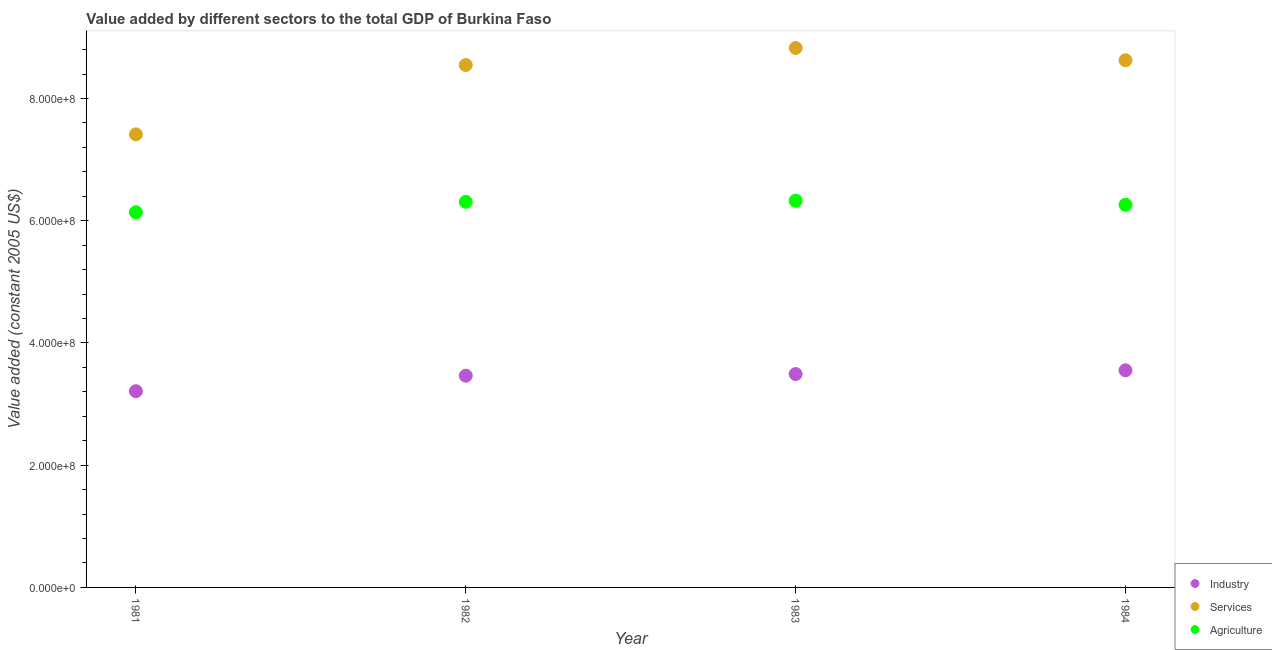What is the value added by services in 1982?
Keep it short and to the point. 8.55e+08. Across all years, what is the maximum value added by agricultural sector?
Provide a succinct answer. 6.33e+08. Across all years, what is the minimum value added by industrial sector?
Your answer should be very brief. 3.21e+08. In which year was the value added by agricultural sector minimum?
Offer a very short reply. 1981. What is the total value added by agricultural sector in the graph?
Offer a terse response. 2.50e+09. What is the difference between the value added by services in 1981 and that in 1984?
Your response must be concise. -1.21e+08. What is the difference between the value added by industrial sector in 1983 and the value added by services in 1984?
Make the answer very short. -5.13e+08. What is the average value added by agricultural sector per year?
Provide a short and direct response. 6.26e+08. In the year 1983, what is the difference between the value added by services and value added by industrial sector?
Your response must be concise. 5.33e+08. What is the ratio of the value added by industrial sector in 1981 to that in 1982?
Offer a terse response. 0.93. Is the value added by agricultural sector in 1983 less than that in 1984?
Offer a very short reply. No. Is the difference between the value added by industrial sector in 1981 and 1983 greater than the difference between the value added by agricultural sector in 1981 and 1983?
Provide a short and direct response. No. What is the difference between the highest and the second highest value added by industrial sector?
Your answer should be very brief. 6.10e+06. What is the difference between the highest and the lowest value added by industrial sector?
Give a very brief answer. 3.42e+07. In how many years, is the value added by agricultural sector greater than the average value added by agricultural sector taken over all years?
Your response must be concise. 3. Is it the case that in every year, the sum of the value added by industrial sector and value added by services is greater than the value added by agricultural sector?
Provide a succinct answer. Yes. Is the value added by industrial sector strictly less than the value added by agricultural sector over the years?
Provide a succinct answer. Yes. How many years are there in the graph?
Give a very brief answer. 4. Where does the legend appear in the graph?
Keep it short and to the point. Bottom right. How are the legend labels stacked?
Provide a succinct answer. Vertical. What is the title of the graph?
Your response must be concise. Value added by different sectors to the total GDP of Burkina Faso. What is the label or title of the X-axis?
Provide a succinct answer. Year. What is the label or title of the Y-axis?
Provide a succinct answer. Value added (constant 2005 US$). What is the Value added (constant 2005 US$) of Industry in 1981?
Your answer should be very brief. 3.21e+08. What is the Value added (constant 2005 US$) in Services in 1981?
Keep it short and to the point. 7.41e+08. What is the Value added (constant 2005 US$) of Agriculture in 1981?
Your answer should be compact. 6.14e+08. What is the Value added (constant 2005 US$) of Industry in 1982?
Give a very brief answer. 3.46e+08. What is the Value added (constant 2005 US$) of Services in 1982?
Keep it short and to the point. 8.55e+08. What is the Value added (constant 2005 US$) of Agriculture in 1982?
Your answer should be very brief. 6.31e+08. What is the Value added (constant 2005 US$) in Industry in 1983?
Provide a short and direct response. 3.49e+08. What is the Value added (constant 2005 US$) in Services in 1983?
Provide a succinct answer. 8.83e+08. What is the Value added (constant 2005 US$) of Agriculture in 1983?
Give a very brief answer. 6.33e+08. What is the Value added (constant 2005 US$) of Industry in 1984?
Your answer should be very brief. 3.55e+08. What is the Value added (constant 2005 US$) in Services in 1984?
Ensure brevity in your answer.  8.62e+08. What is the Value added (constant 2005 US$) of Agriculture in 1984?
Provide a short and direct response. 6.26e+08. Across all years, what is the maximum Value added (constant 2005 US$) in Industry?
Your answer should be very brief. 3.55e+08. Across all years, what is the maximum Value added (constant 2005 US$) of Services?
Offer a very short reply. 8.83e+08. Across all years, what is the maximum Value added (constant 2005 US$) of Agriculture?
Make the answer very short. 6.33e+08. Across all years, what is the minimum Value added (constant 2005 US$) of Industry?
Your response must be concise. 3.21e+08. Across all years, what is the minimum Value added (constant 2005 US$) in Services?
Make the answer very short. 7.41e+08. Across all years, what is the minimum Value added (constant 2005 US$) of Agriculture?
Provide a short and direct response. 6.14e+08. What is the total Value added (constant 2005 US$) in Industry in the graph?
Your response must be concise. 1.37e+09. What is the total Value added (constant 2005 US$) in Services in the graph?
Provide a short and direct response. 3.34e+09. What is the total Value added (constant 2005 US$) in Agriculture in the graph?
Provide a succinct answer. 2.50e+09. What is the difference between the Value added (constant 2005 US$) of Industry in 1981 and that in 1982?
Make the answer very short. -2.54e+07. What is the difference between the Value added (constant 2005 US$) of Services in 1981 and that in 1982?
Offer a terse response. -1.13e+08. What is the difference between the Value added (constant 2005 US$) in Agriculture in 1981 and that in 1982?
Give a very brief answer. -1.71e+07. What is the difference between the Value added (constant 2005 US$) in Industry in 1981 and that in 1983?
Provide a short and direct response. -2.81e+07. What is the difference between the Value added (constant 2005 US$) of Services in 1981 and that in 1983?
Provide a succinct answer. -1.41e+08. What is the difference between the Value added (constant 2005 US$) in Agriculture in 1981 and that in 1983?
Give a very brief answer. -1.89e+07. What is the difference between the Value added (constant 2005 US$) of Industry in 1981 and that in 1984?
Provide a succinct answer. -3.42e+07. What is the difference between the Value added (constant 2005 US$) of Services in 1981 and that in 1984?
Provide a short and direct response. -1.21e+08. What is the difference between the Value added (constant 2005 US$) in Agriculture in 1981 and that in 1984?
Your answer should be very brief. -1.22e+07. What is the difference between the Value added (constant 2005 US$) of Industry in 1982 and that in 1983?
Provide a short and direct response. -2.71e+06. What is the difference between the Value added (constant 2005 US$) of Services in 1982 and that in 1983?
Your response must be concise. -2.79e+07. What is the difference between the Value added (constant 2005 US$) of Agriculture in 1982 and that in 1983?
Ensure brevity in your answer.  -1.83e+06. What is the difference between the Value added (constant 2005 US$) in Industry in 1982 and that in 1984?
Your response must be concise. -8.82e+06. What is the difference between the Value added (constant 2005 US$) in Services in 1982 and that in 1984?
Ensure brevity in your answer.  -7.79e+06. What is the difference between the Value added (constant 2005 US$) in Agriculture in 1982 and that in 1984?
Provide a short and direct response. 4.89e+06. What is the difference between the Value added (constant 2005 US$) of Industry in 1983 and that in 1984?
Provide a short and direct response. -6.10e+06. What is the difference between the Value added (constant 2005 US$) of Services in 1983 and that in 1984?
Your response must be concise. 2.01e+07. What is the difference between the Value added (constant 2005 US$) of Agriculture in 1983 and that in 1984?
Your response must be concise. 6.72e+06. What is the difference between the Value added (constant 2005 US$) of Industry in 1981 and the Value added (constant 2005 US$) of Services in 1982?
Give a very brief answer. -5.34e+08. What is the difference between the Value added (constant 2005 US$) of Industry in 1981 and the Value added (constant 2005 US$) of Agriculture in 1982?
Provide a succinct answer. -3.10e+08. What is the difference between the Value added (constant 2005 US$) in Services in 1981 and the Value added (constant 2005 US$) in Agriculture in 1982?
Make the answer very short. 1.10e+08. What is the difference between the Value added (constant 2005 US$) of Industry in 1981 and the Value added (constant 2005 US$) of Services in 1983?
Offer a very short reply. -5.62e+08. What is the difference between the Value added (constant 2005 US$) of Industry in 1981 and the Value added (constant 2005 US$) of Agriculture in 1983?
Keep it short and to the point. -3.12e+08. What is the difference between the Value added (constant 2005 US$) of Services in 1981 and the Value added (constant 2005 US$) of Agriculture in 1983?
Offer a terse response. 1.08e+08. What is the difference between the Value added (constant 2005 US$) in Industry in 1981 and the Value added (constant 2005 US$) in Services in 1984?
Your answer should be compact. -5.41e+08. What is the difference between the Value added (constant 2005 US$) of Industry in 1981 and the Value added (constant 2005 US$) of Agriculture in 1984?
Keep it short and to the point. -3.05e+08. What is the difference between the Value added (constant 2005 US$) of Services in 1981 and the Value added (constant 2005 US$) of Agriculture in 1984?
Ensure brevity in your answer.  1.15e+08. What is the difference between the Value added (constant 2005 US$) in Industry in 1982 and the Value added (constant 2005 US$) in Services in 1983?
Your response must be concise. -5.36e+08. What is the difference between the Value added (constant 2005 US$) in Industry in 1982 and the Value added (constant 2005 US$) in Agriculture in 1983?
Offer a very short reply. -2.86e+08. What is the difference between the Value added (constant 2005 US$) of Services in 1982 and the Value added (constant 2005 US$) of Agriculture in 1983?
Ensure brevity in your answer.  2.22e+08. What is the difference between the Value added (constant 2005 US$) of Industry in 1982 and the Value added (constant 2005 US$) of Services in 1984?
Offer a very short reply. -5.16e+08. What is the difference between the Value added (constant 2005 US$) in Industry in 1982 and the Value added (constant 2005 US$) in Agriculture in 1984?
Provide a succinct answer. -2.80e+08. What is the difference between the Value added (constant 2005 US$) in Services in 1982 and the Value added (constant 2005 US$) in Agriculture in 1984?
Offer a terse response. 2.29e+08. What is the difference between the Value added (constant 2005 US$) of Industry in 1983 and the Value added (constant 2005 US$) of Services in 1984?
Your answer should be very brief. -5.13e+08. What is the difference between the Value added (constant 2005 US$) in Industry in 1983 and the Value added (constant 2005 US$) in Agriculture in 1984?
Your answer should be compact. -2.77e+08. What is the difference between the Value added (constant 2005 US$) in Services in 1983 and the Value added (constant 2005 US$) in Agriculture in 1984?
Offer a terse response. 2.57e+08. What is the average Value added (constant 2005 US$) of Industry per year?
Your response must be concise. 3.43e+08. What is the average Value added (constant 2005 US$) of Services per year?
Offer a very short reply. 8.35e+08. What is the average Value added (constant 2005 US$) of Agriculture per year?
Give a very brief answer. 6.26e+08. In the year 1981, what is the difference between the Value added (constant 2005 US$) of Industry and Value added (constant 2005 US$) of Services?
Your response must be concise. -4.20e+08. In the year 1981, what is the difference between the Value added (constant 2005 US$) in Industry and Value added (constant 2005 US$) in Agriculture?
Keep it short and to the point. -2.93e+08. In the year 1981, what is the difference between the Value added (constant 2005 US$) in Services and Value added (constant 2005 US$) in Agriculture?
Your response must be concise. 1.27e+08. In the year 1982, what is the difference between the Value added (constant 2005 US$) in Industry and Value added (constant 2005 US$) in Services?
Your answer should be compact. -5.08e+08. In the year 1982, what is the difference between the Value added (constant 2005 US$) of Industry and Value added (constant 2005 US$) of Agriculture?
Offer a very short reply. -2.85e+08. In the year 1982, what is the difference between the Value added (constant 2005 US$) in Services and Value added (constant 2005 US$) in Agriculture?
Provide a short and direct response. 2.24e+08. In the year 1983, what is the difference between the Value added (constant 2005 US$) of Industry and Value added (constant 2005 US$) of Services?
Offer a very short reply. -5.33e+08. In the year 1983, what is the difference between the Value added (constant 2005 US$) in Industry and Value added (constant 2005 US$) in Agriculture?
Your answer should be compact. -2.84e+08. In the year 1983, what is the difference between the Value added (constant 2005 US$) of Services and Value added (constant 2005 US$) of Agriculture?
Your answer should be very brief. 2.50e+08. In the year 1984, what is the difference between the Value added (constant 2005 US$) of Industry and Value added (constant 2005 US$) of Services?
Provide a succinct answer. -5.07e+08. In the year 1984, what is the difference between the Value added (constant 2005 US$) of Industry and Value added (constant 2005 US$) of Agriculture?
Provide a succinct answer. -2.71e+08. In the year 1984, what is the difference between the Value added (constant 2005 US$) in Services and Value added (constant 2005 US$) in Agriculture?
Your response must be concise. 2.36e+08. What is the ratio of the Value added (constant 2005 US$) in Industry in 1981 to that in 1982?
Offer a terse response. 0.93. What is the ratio of the Value added (constant 2005 US$) in Services in 1981 to that in 1982?
Ensure brevity in your answer.  0.87. What is the ratio of the Value added (constant 2005 US$) of Agriculture in 1981 to that in 1982?
Give a very brief answer. 0.97. What is the ratio of the Value added (constant 2005 US$) in Industry in 1981 to that in 1983?
Your answer should be compact. 0.92. What is the ratio of the Value added (constant 2005 US$) in Services in 1981 to that in 1983?
Keep it short and to the point. 0.84. What is the ratio of the Value added (constant 2005 US$) of Agriculture in 1981 to that in 1983?
Your response must be concise. 0.97. What is the ratio of the Value added (constant 2005 US$) in Industry in 1981 to that in 1984?
Give a very brief answer. 0.9. What is the ratio of the Value added (constant 2005 US$) in Services in 1981 to that in 1984?
Your response must be concise. 0.86. What is the ratio of the Value added (constant 2005 US$) of Agriculture in 1981 to that in 1984?
Provide a succinct answer. 0.98. What is the ratio of the Value added (constant 2005 US$) of Industry in 1982 to that in 1983?
Your answer should be compact. 0.99. What is the ratio of the Value added (constant 2005 US$) in Services in 1982 to that in 1983?
Your answer should be compact. 0.97. What is the ratio of the Value added (constant 2005 US$) in Agriculture in 1982 to that in 1983?
Provide a short and direct response. 1. What is the ratio of the Value added (constant 2005 US$) in Industry in 1982 to that in 1984?
Give a very brief answer. 0.98. What is the ratio of the Value added (constant 2005 US$) in Services in 1982 to that in 1984?
Your answer should be very brief. 0.99. What is the ratio of the Value added (constant 2005 US$) in Agriculture in 1982 to that in 1984?
Your response must be concise. 1.01. What is the ratio of the Value added (constant 2005 US$) of Industry in 1983 to that in 1984?
Offer a terse response. 0.98. What is the ratio of the Value added (constant 2005 US$) of Services in 1983 to that in 1984?
Provide a short and direct response. 1.02. What is the ratio of the Value added (constant 2005 US$) of Agriculture in 1983 to that in 1984?
Your response must be concise. 1.01. What is the difference between the highest and the second highest Value added (constant 2005 US$) in Industry?
Your answer should be very brief. 6.10e+06. What is the difference between the highest and the second highest Value added (constant 2005 US$) in Services?
Give a very brief answer. 2.01e+07. What is the difference between the highest and the second highest Value added (constant 2005 US$) of Agriculture?
Provide a short and direct response. 1.83e+06. What is the difference between the highest and the lowest Value added (constant 2005 US$) of Industry?
Keep it short and to the point. 3.42e+07. What is the difference between the highest and the lowest Value added (constant 2005 US$) in Services?
Make the answer very short. 1.41e+08. What is the difference between the highest and the lowest Value added (constant 2005 US$) in Agriculture?
Make the answer very short. 1.89e+07. 